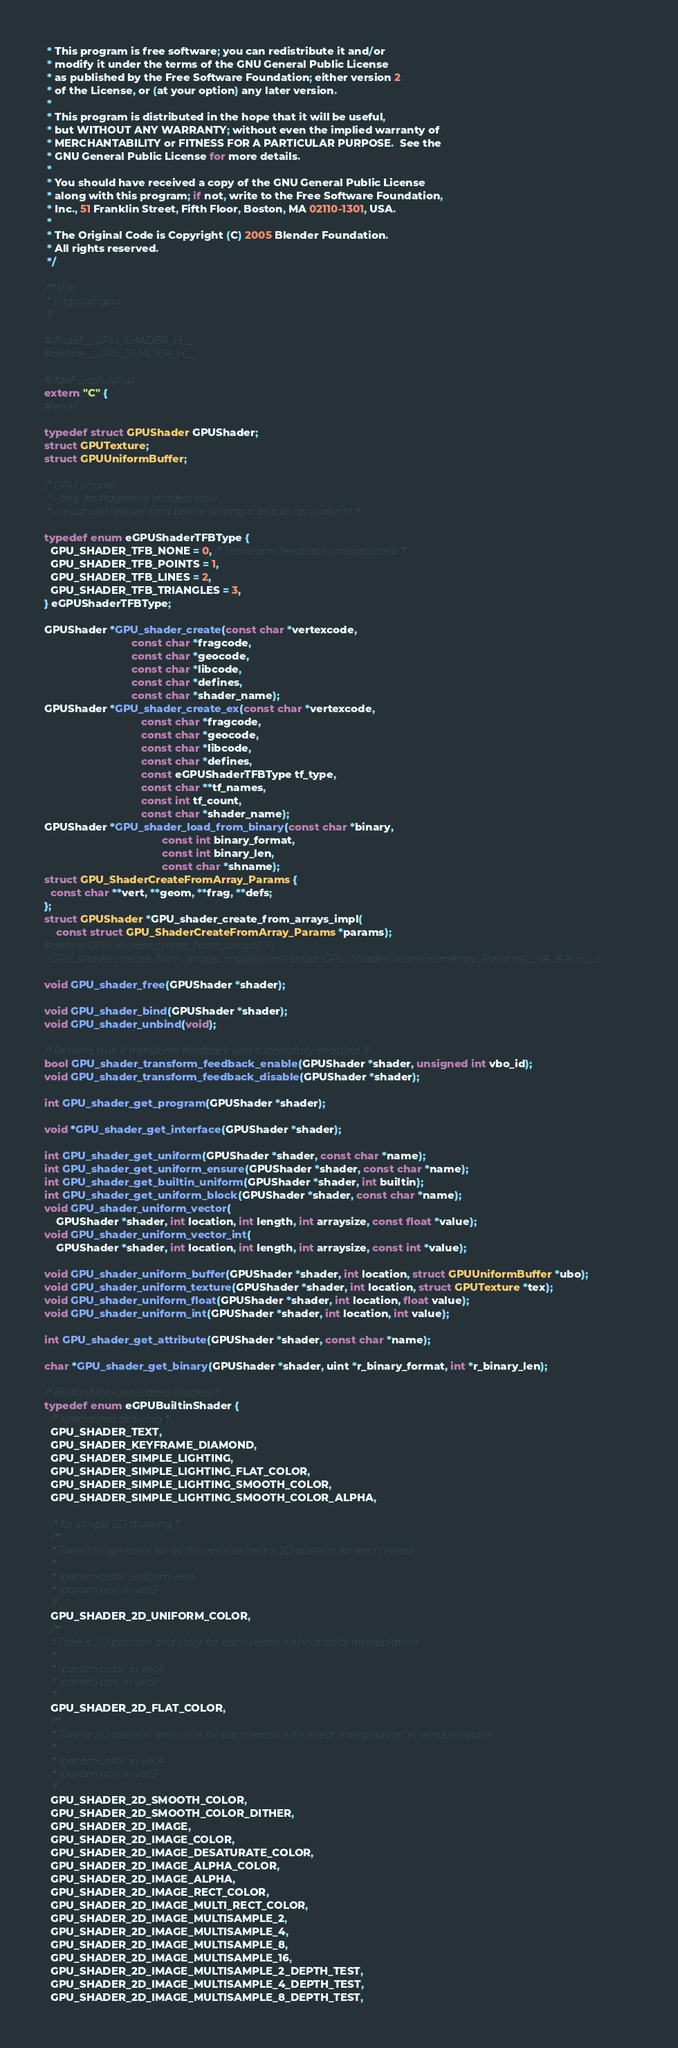<code> <loc_0><loc_0><loc_500><loc_500><_C_> * This program is free software; you can redistribute it and/or
 * modify it under the terms of the GNU General Public License
 * as published by the Free Software Foundation; either version 2
 * of the License, or (at your option) any later version.
 *
 * This program is distributed in the hope that it will be useful,
 * but WITHOUT ANY WARRANTY; without even the implied warranty of
 * MERCHANTABILITY or FITNESS FOR A PARTICULAR PURPOSE.  See the
 * GNU General Public License for more details.
 *
 * You should have received a copy of the GNU General Public License
 * along with this program; if not, write to the Free Software Foundation,
 * Inc., 51 Franklin Street, Fifth Floor, Boston, MA 02110-1301, USA.
 *
 * The Original Code is Copyright (C) 2005 Blender Foundation.
 * All rights reserved.
 */

/** \file
 * \ingroup gpu
 */

#ifndef __GPU_SHADER_H__
#define __GPU_SHADER_H__

#ifdef __cplusplus
extern "C" {
#endif

typedef struct GPUShader GPUShader;
struct GPUTexture;
struct GPUUniformBuffer;

/* GPU Shader
 * - only for fragment shaders now
 * - must call texture bind before setting a texture as uniform! */

typedef enum eGPUShaderTFBType {
  GPU_SHADER_TFB_NONE = 0, /* Transform feedback unsupported. */
  GPU_SHADER_TFB_POINTS = 1,
  GPU_SHADER_TFB_LINES = 2,
  GPU_SHADER_TFB_TRIANGLES = 3,
} eGPUShaderTFBType;

GPUShader *GPU_shader_create(const char *vertexcode,
                             const char *fragcode,
                             const char *geocode,
                             const char *libcode,
                             const char *defines,
                             const char *shader_name);
GPUShader *GPU_shader_create_ex(const char *vertexcode,
                                const char *fragcode,
                                const char *geocode,
                                const char *libcode,
                                const char *defines,
                                const eGPUShaderTFBType tf_type,
                                const char **tf_names,
                                const int tf_count,
                                const char *shader_name);
GPUShader *GPU_shader_load_from_binary(const char *binary,
                                       const int binary_format,
                                       const int binary_len,
                                       const char *shname);
struct GPU_ShaderCreateFromArray_Params {
  const char **vert, **geom, **frag, **defs;
};
struct GPUShader *GPU_shader_create_from_arrays_impl(
    const struct GPU_ShaderCreateFromArray_Params *params);
#define GPU_shader_create_from_arrays(...) \
  GPU_shader_create_from_arrays_impl(&(const struct GPU_ShaderCreateFromArray_Params)__VA_ARGS__)

void GPU_shader_free(GPUShader *shader);

void GPU_shader_bind(GPUShader *shader);
void GPU_shader_unbind(void);

/* Returns true if transform feedback was successfully enabled. */
bool GPU_shader_transform_feedback_enable(GPUShader *shader, unsigned int vbo_id);
void GPU_shader_transform_feedback_disable(GPUShader *shader);

int GPU_shader_get_program(GPUShader *shader);

void *GPU_shader_get_interface(GPUShader *shader);

int GPU_shader_get_uniform(GPUShader *shader, const char *name);
int GPU_shader_get_uniform_ensure(GPUShader *shader, const char *name);
int GPU_shader_get_builtin_uniform(GPUShader *shader, int builtin);
int GPU_shader_get_uniform_block(GPUShader *shader, const char *name);
void GPU_shader_uniform_vector(
    GPUShader *shader, int location, int length, int arraysize, const float *value);
void GPU_shader_uniform_vector_int(
    GPUShader *shader, int location, int length, int arraysize, const int *value);

void GPU_shader_uniform_buffer(GPUShader *shader, int location, struct GPUUniformBuffer *ubo);
void GPU_shader_uniform_texture(GPUShader *shader, int location, struct GPUTexture *tex);
void GPU_shader_uniform_float(GPUShader *shader, int location, float value);
void GPU_shader_uniform_int(GPUShader *shader, int location, int value);

int GPU_shader_get_attribute(GPUShader *shader, const char *name);

char *GPU_shader_get_binary(GPUShader *shader, uint *r_binary_format, int *r_binary_len);

/* Builtin/Non-generated shaders */
typedef enum eGPUBuiltinShader {
  /* specialized drawing */
  GPU_SHADER_TEXT,
  GPU_SHADER_KEYFRAME_DIAMOND,
  GPU_SHADER_SIMPLE_LIGHTING,
  GPU_SHADER_SIMPLE_LIGHTING_FLAT_COLOR,
  GPU_SHADER_SIMPLE_LIGHTING_SMOOTH_COLOR,
  GPU_SHADER_SIMPLE_LIGHTING_SMOOTH_COLOR_ALPHA,

  /* for simple 2D drawing */
  /**
   * Take a single color for all the vertices and a 2D position for each vertex.
   *
   * \param color: uniform vec4
   * \param pos: in vec2
   */
  GPU_SHADER_2D_UNIFORM_COLOR,
  /**
   * Take a 2D position and color for each vertex without color interpolation.
   *
   * \param color: in vec4
   * \param pos: in vec2
   */
  GPU_SHADER_2D_FLAT_COLOR,
  /**
   * Take a 2D position and color for each vertex with linear interpolation in window space.
   *
   * \param color: in vec4
   * \param pos: in vec2
   */
  GPU_SHADER_2D_SMOOTH_COLOR,
  GPU_SHADER_2D_SMOOTH_COLOR_DITHER,
  GPU_SHADER_2D_IMAGE,
  GPU_SHADER_2D_IMAGE_COLOR,
  GPU_SHADER_2D_IMAGE_DESATURATE_COLOR,
  GPU_SHADER_2D_IMAGE_ALPHA_COLOR,
  GPU_SHADER_2D_IMAGE_ALPHA,
  GPU_SHADER_2D_IMAGE_RECT_COLOR,
  GPU_SHADER_2D_IMAGE_MULTI_RECT_COLOR,
  GPU_SHADER_2D_IMAGE_MULTISAMPLE_2,
  GPU_SHADER_2D_IMAGE_MULTISAMPLE_4,
  GPU_SHADER_2D_IMAGE_MULTISAMPLE_8,
  GPU_SHADER_2D_IMAGE_MULTISAMPLE_16,
  GPU_SHADER_2D_IMAGE_MULTISAMPLE_2_DEPTH_TEST,
  GPU_SHADER_2D_IMAGE_MULTISAMPLE_4_DEPTH_TEST,
  GPU_SHADER_2D_IMAGE_MULTISAMPLE_8_DEPTH_TEST,</code> 